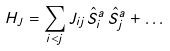Convert formula to latex. <formula><loc_0><loc_0><loc_500><loc_500>H _ { J } = \sum _ { i < j } J _ { i j } \hat { S } ^ { a } _ { i } \, \hat { S } ^ { a } _ { j } + \dots</formula> 